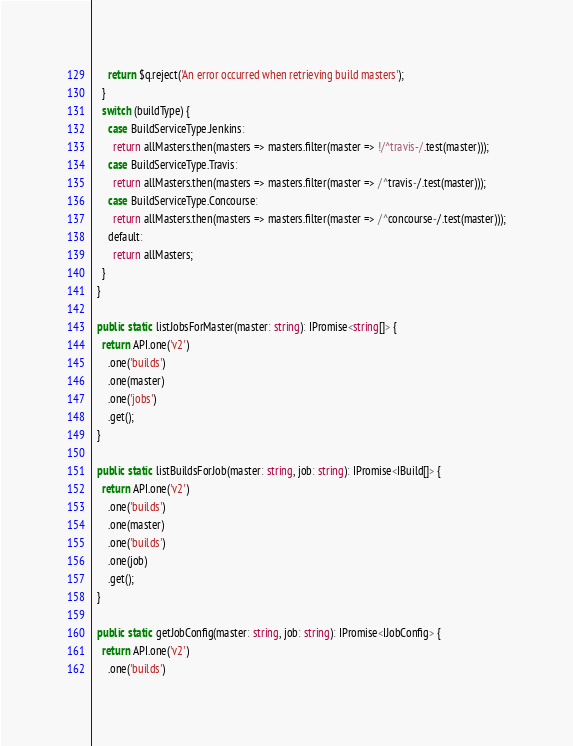<code> <loc_0><loc_0><loc_500><loc_500><_TypeScript_>      return $q.reject('An error occurred when retrieving build masters');
    }
    switch (buildType) {
      case BuildServiceType.Jenkins:
        return allMasters.then(masters => masters.filter(master => !/^travis-/.test(master)));
      case BuildServiceType.Travis:
        return allMasters.then(masters => masters.filter(master => /^travis-/.test(master)));
      case BuildServiceType.Concourse:
        return allMasters.then(masters => masters.filter(master => /^concourse-/.test(master)));
      default:
        return allMasters;
    }
  }

  public static listJobsForMaster(master: string): IPromise<string[]> {
    return API.one('v2')
      .one('builds')
      .one(master)
      .one('jobs')
      .get();
  }

  public static listBuildsForJob(master: string, job: string): IPromise<IBuild[]> {
    return API.one('v2')
      .one('builds')
      .one(master)
      .one('builds')
      .one(job)
      .get();
  }

  public static getJobConfig(master: string, job: string): IPromise<IJobConfig> {
    return API.one('v2')
      .one('builds')</code> 